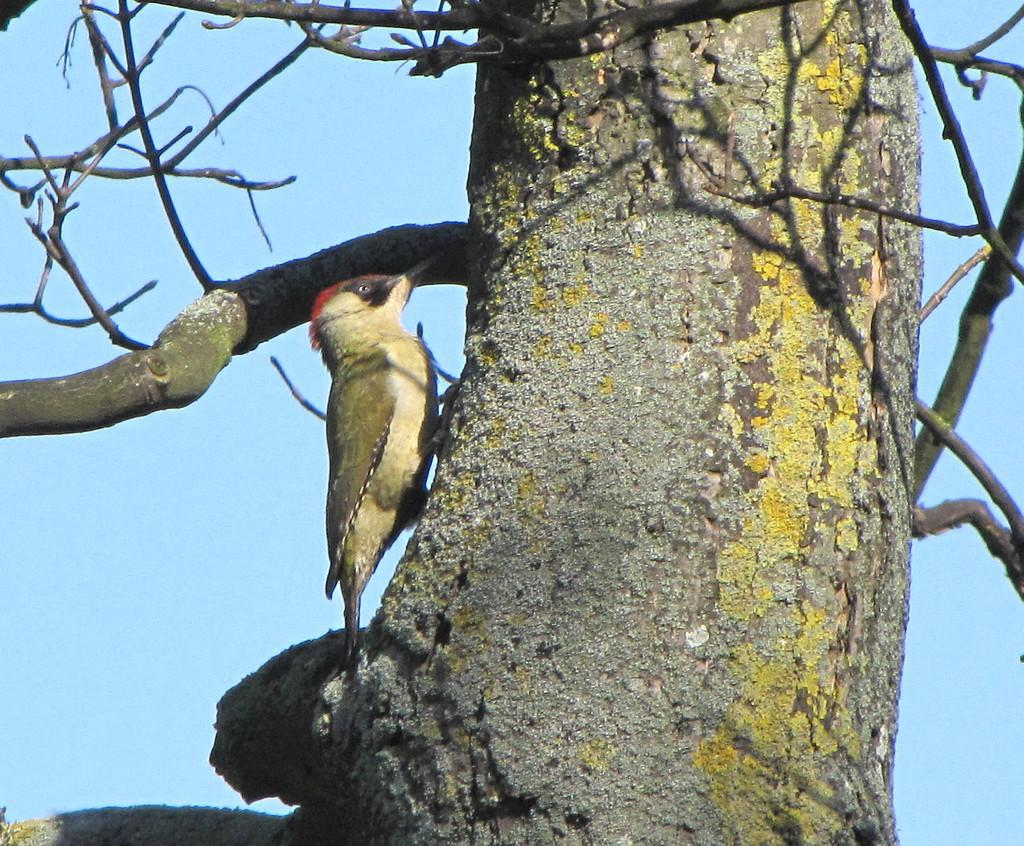What type of animal can be seen in the image? There is a bird in the image. Where is the bird located? The bird is on a tree trunk. What can be seen in the background of the image? There is sky visible in the background of the image. What is the condition of the bird's skin in the image? There is no information about the bird's skin condition in the image. How much of the earth can be seen in the image? The image does not show any part of the earth; it only shows a bird on a tree trunk and sky in the background. 